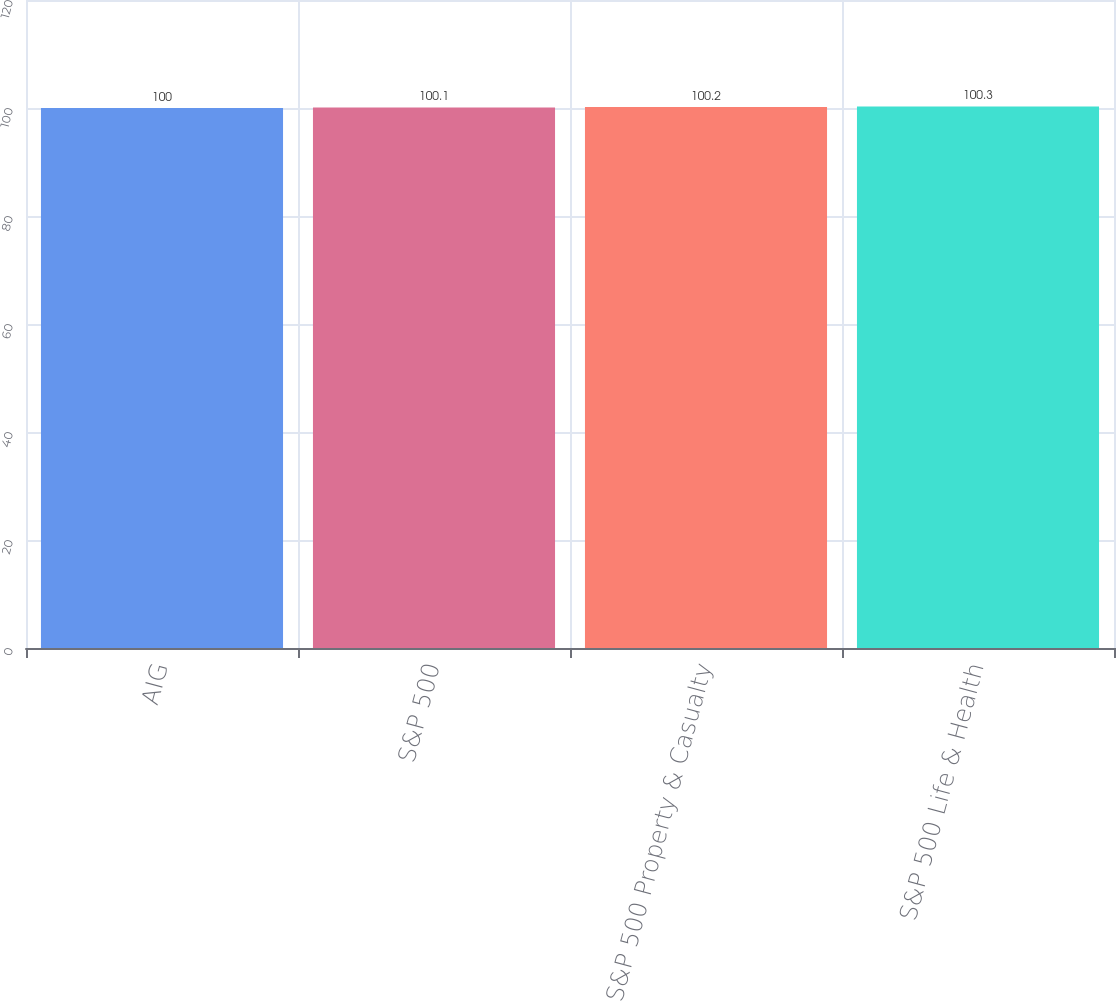Convert chart to OTSL. <chart><loc_0><loc_0><loc_500><loc_500><bar_chart><fcel>AIG<fcel>S&P 500<fcel>S&P 500 Property & Casualty<fcel>S&P 500 Life & Health<nl><fcel>100<fcel>100.1<fcel>100.2<fcel>100.3<nl></chart> 